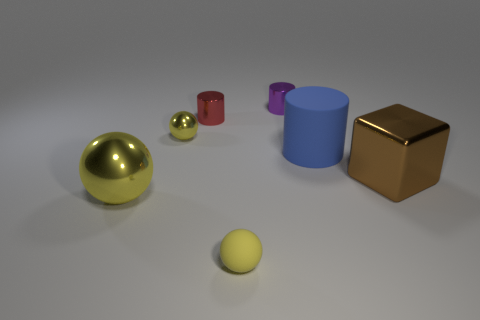The small object that is the same color as the rubber ball is what shape?
Give a very brief answer. Sphere. There is another tiny object that is the same color as the tiny rubber thing; what is its material?
Your answer should be compact. Metal. There is a metallic block; are there any blue rubber objects on the right side of it?
Offer a very short reply. No. Are there any other yellow metal things that have the same shape as the big yellow metallic object?
Your response must be concise. Yes. Do the tiny red object behind the big yellow metal sphere and the small yellow object behind the brown metallic block have the same shape?
Provide a succinct answer. No. Is there a gray rubber block that has the same size as the red cylinder?
Make the answer very short. No. Is the number of small red things that are on the right side of the small matte object the same as the number of big matte things that are in front of the tiny purple metallic object?
Offer a very short reply. No. Do the yellow sphere that is behind the brown thing and the small ball in front of the brown cube have the same material?
Your answer should be compact. No. What is the material of the big cylinder?
Make the answer very short. Rubber. What number of other things are there of the same color as the metallic block?
Offer a very short reply. 0. 